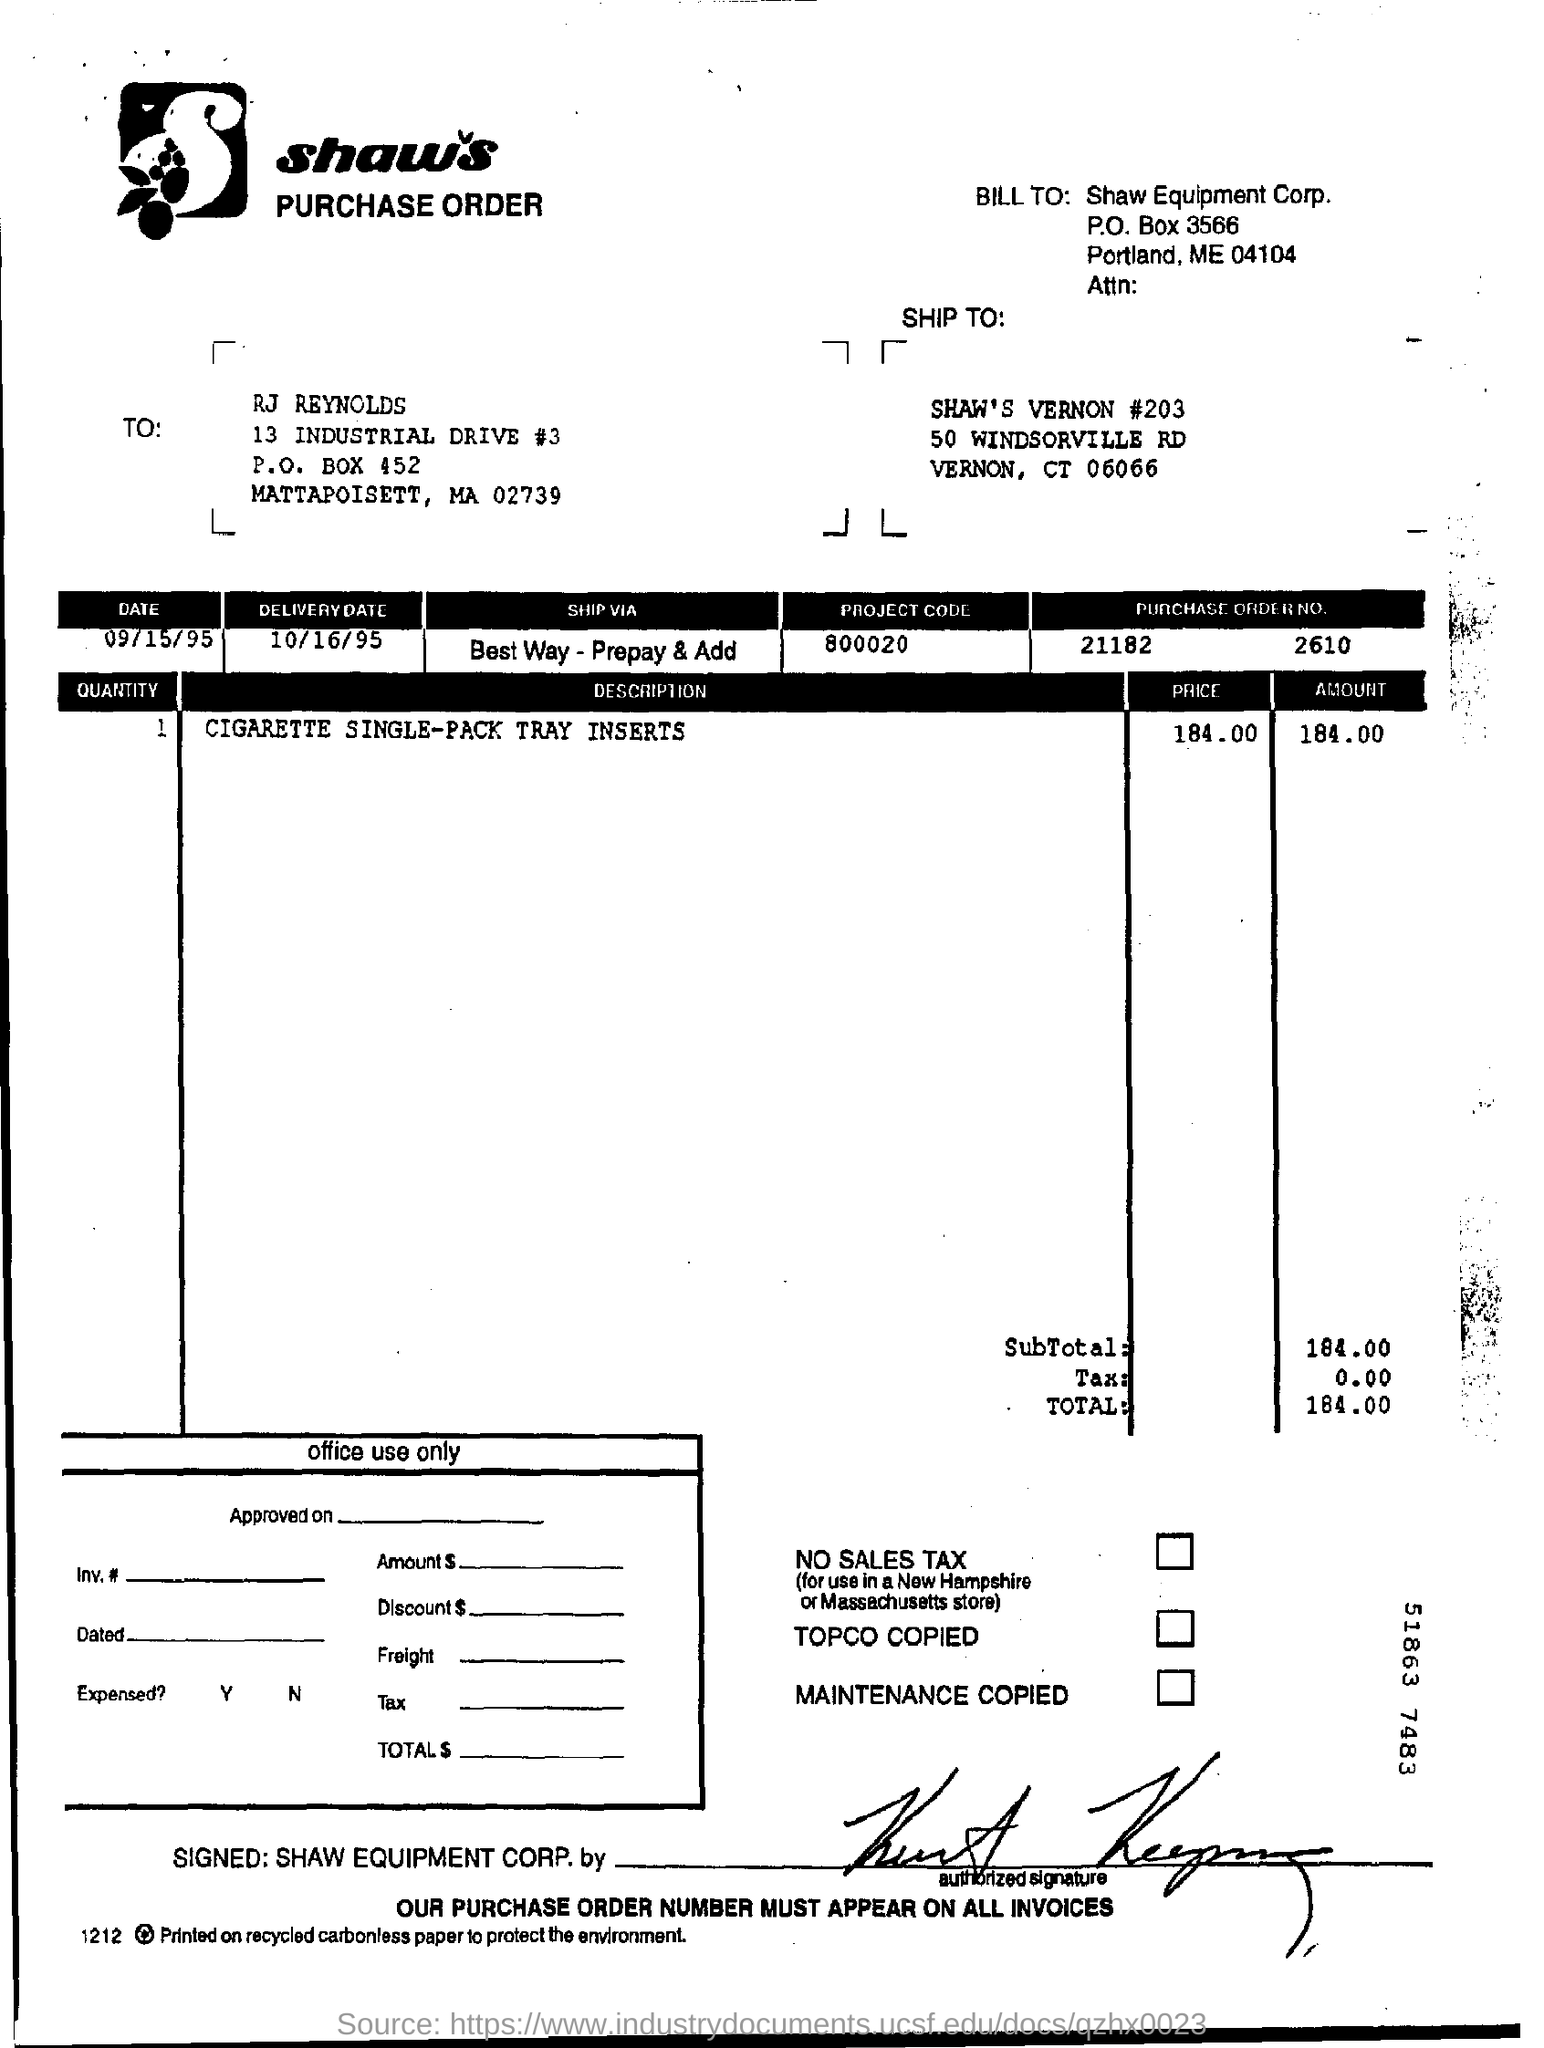Highlight a few significant elements in this photo. The project code mentioned in the purchase order is 800020.... The document contains a purchase order number, 21182, and a supplier order number, 2610. The delivery date mentioned in the purchase order is 10/16/95. The total amount given in the purchase order is 184.00. The purchase order describes the quantity of cigarette single-pack tray inserts. 